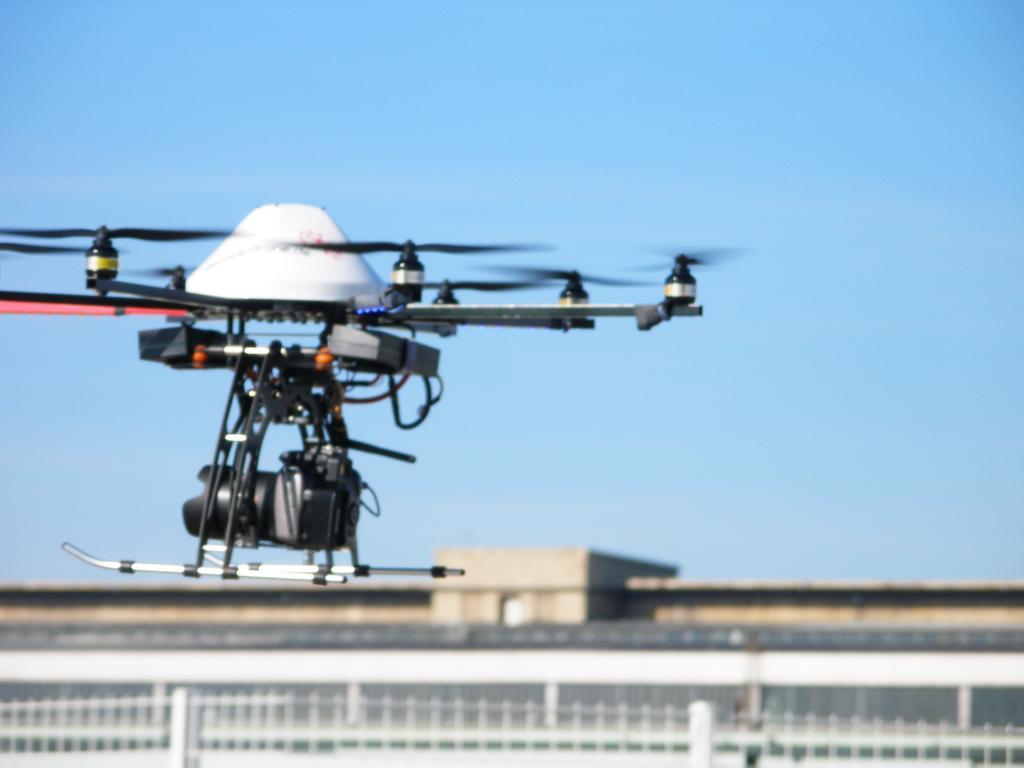Could you give a brief overview of what you see in this image? In this picture we can see a drone in the air, fence, some objects and in the background we can see the sky. 